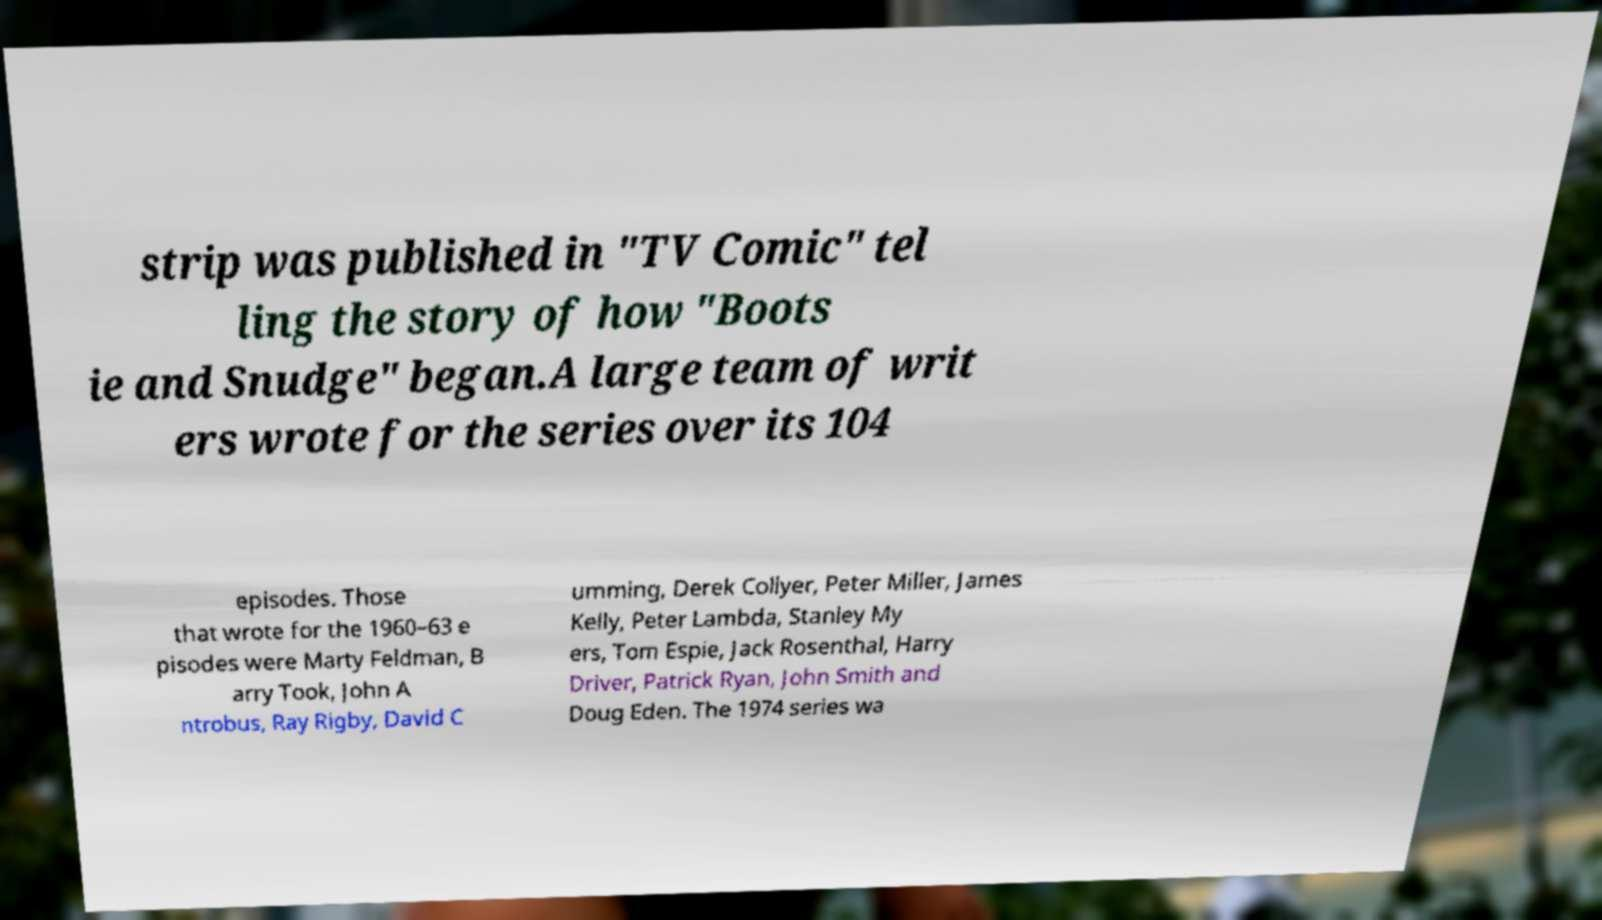Please identify and transcribe the text found in this image. strip was published in "TV Comic" tel ling the story of how "Boots ie and Snudge" began.A large team of writ ers wrote for the series over its 104 episodes. Those that wrote for the 1960–63 e pisodes were Marty Feldman, B arry Took, John A ntrobus, Ray Rigby, David C umming, Derek Collyer, Peter Miller, James Kelly, Peter Lambda, Stanley My ers, Tom Espie, Jack Rosenthal, Harry Driver, Patrick Ryan, John Smith and Doug Eden. The 1974 series wa 